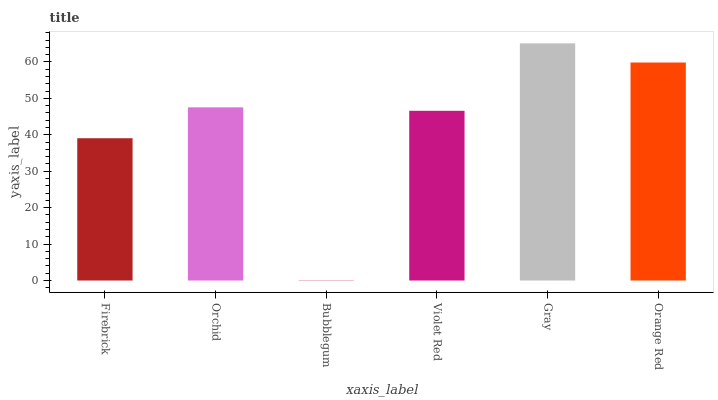Is Bubblegum the minimum?
Answer yes or no. Yes. Is Gray the maximum?
Answer yes or no. Yes. Is Orchid the minimum?
Answer yes or no. No. Is Orchid the maximum?
Answer yes or no. No. Is Orchid greater than Firebrick?
Answer yes or no. Yes. Is Firebrick less than Orchid?
Answer yes or no. Yes. Is Firebrick greater than Orchid?
Answer yes or no. No. Is Orchid less than Firebrick?
Answer yes or no. No. Is Orchid the high median?
Answer yes or no. Yes. Is Violet Red the low median?
Answer yes or no. Yes. Is Orange Red the high median?
Answer yes or no. No. Is Orange Red the low median?
Answer yes or no. No. 